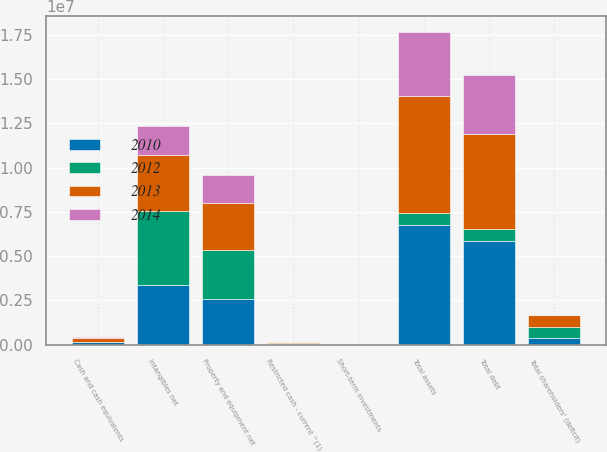<chart> <loc_0><loc_0><loc_500><loc_500><stacked_bar_chart><ecel><fcel>Cash and cash equivalents<fcel>Restricted cash - current ^(1)<fcel>Short-term investments<fcel>Property and equipment net<fcel>Intangibles net<fcel>Total assets<fcel>Total debt<fcel>Total shareholders' (deficit)<nl><fcel>2012<fcel>39443<fcel>52519<fcel>5549<fcel>2.76242e+06<fcel>4.18954e+06<fcel>656896<fcel>656896<fcel>660800<nl><fcel>2010<fcel>122112<fcel>47305<fcel>5446<fcel>2.57844e+06<fcel>3.3872e+06<fcel>6.78319e+06<fcel>5.87661e+06<fcel>356966<nl><fcel>2013<fcel>233099<fcel>27708<fcel>5471<fcel>2.67132e+06<fcel>3.13413e+06<fcel>6.61591e+06<fcel>5.3561e+06<fcel>652991<nl><fcel>2014<fcel>47316<fcel>22266<fcel>5773<fcel>1.58339e+06<fcel>1.63978e+06<fcel>3.6064e+06<fcel>3.35448e+06<fcel>11313<nl></chart> 